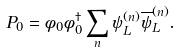<formula> <loc_0><loc_0><loc_500><loc_500>P _ { 0 } = \phi _ { 0 } \phi _ { 0 } ^ { \dagger } \sum _ { n } \psi _ { L } ^ { ( n ) } \overline { \psi } _ { L } ^ { ( n ) } .</formula> 